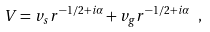Convert formula to latex. <formula><loc_0><loc_0><loc_500><loc_500>V = v _ { s } r ^ { - 1 / 2 + i \alpha } + v _ { g } r ^ { - 1 / 2 + i \alpha } \ ,</formula> 